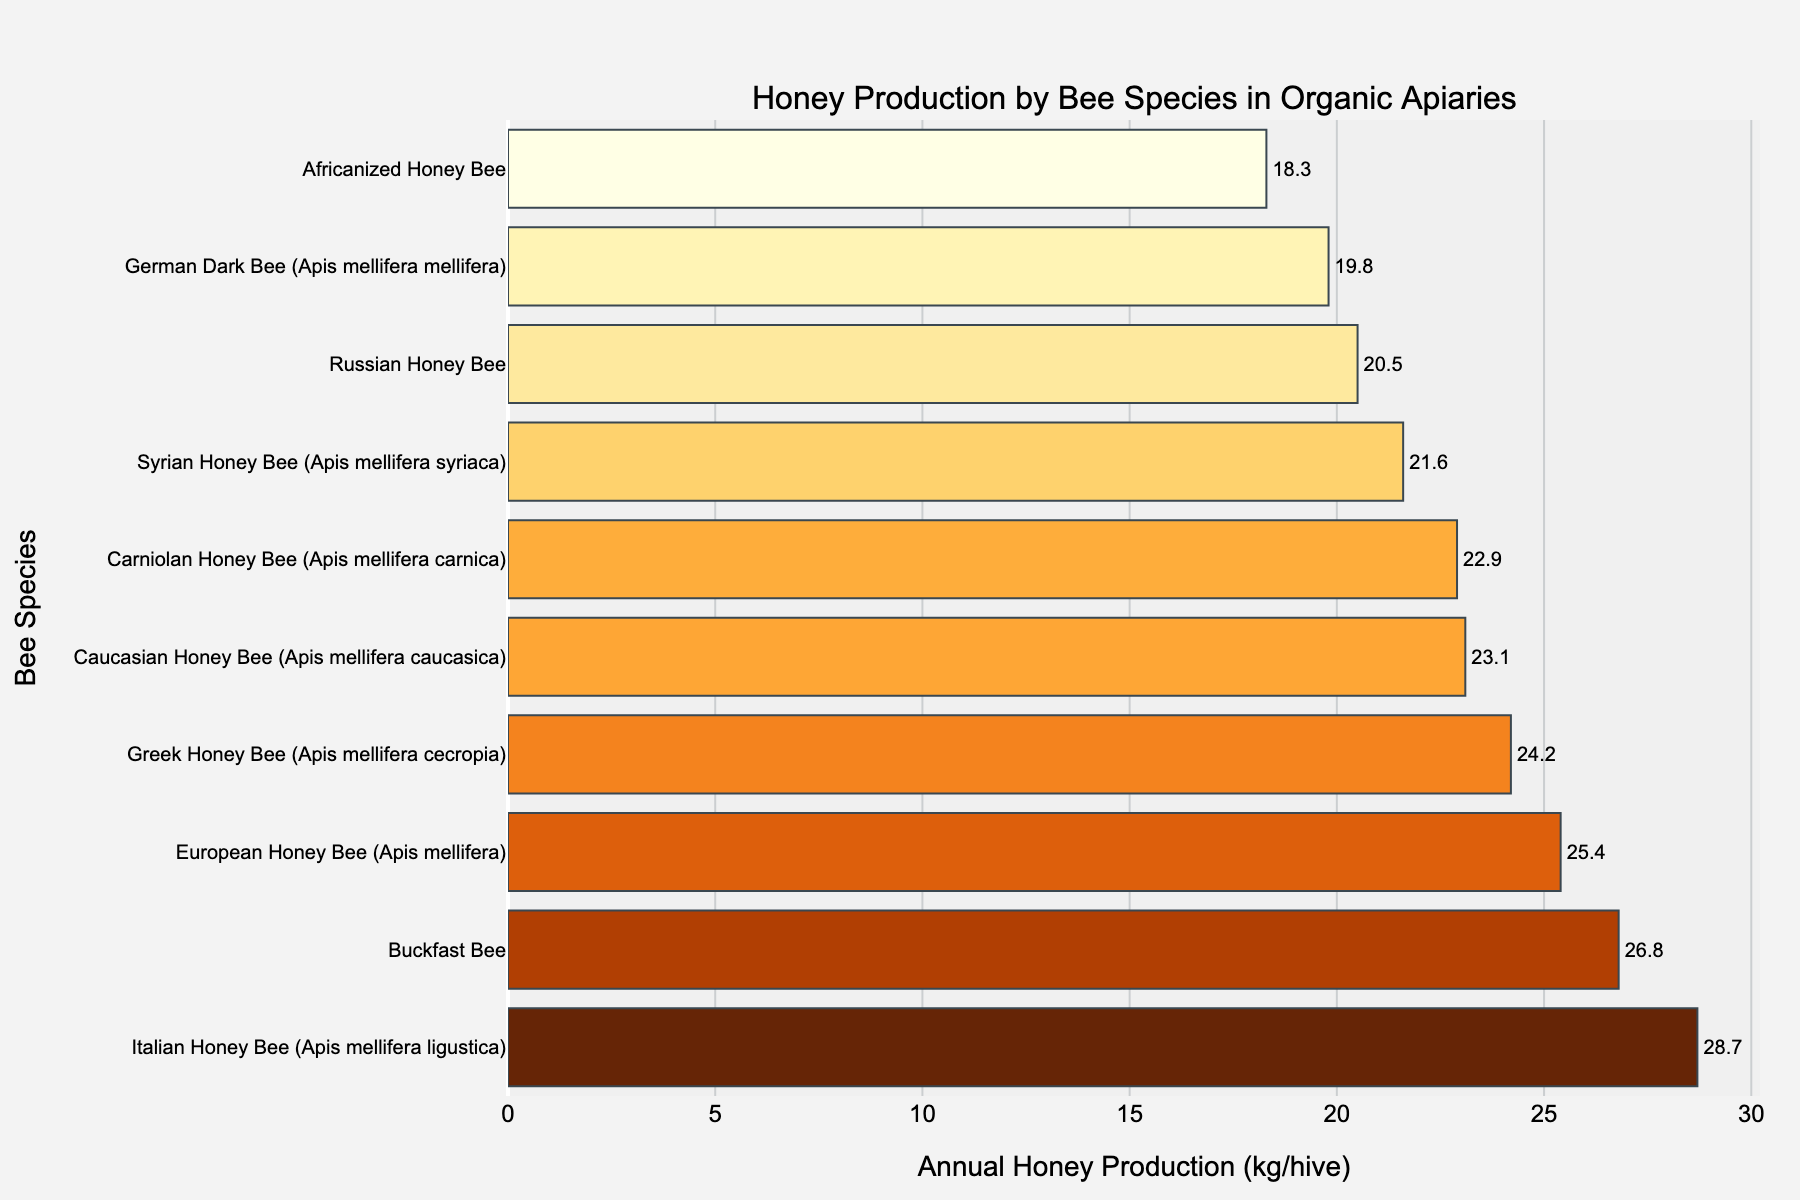Which bee species has the highest annual honey production? The bar chart shows the annual honey production for each bee species. The species with the longest bar has the highest production.
Answer: Italian Honey Bee (Apis mellifera ligustica) Which bee species has the lowest annual honey production? To find the species with the lowest production, look for the shortest bar in the chart.
Answer: Africanized Honey Bee What is the difference in annual honey production between the Italian Honey Bee and the European Honey Bee? Find the lengths of the bars for Italian Honey Bee (28.7 kg/hive) and European Honey Bee (25.4 kg/hive). Subtract the smaller value from the larger value to get the difference.
Answer: 3.3 kg/hive How many bee species have an annual honey production greater than 25 kg per hive? Count the number of bars that extend beyond the 25 kg/hive mark.
Answer: 3 Among the species listed, which one is closest to the median annual honey production value? First, list all production values in ascending order: 18.3, 19.8, 20.5, 21.6, 22.9, 23.1, 24.2, 25.4, 26.8, 28.7. The median value is the middle one (or average of the two middle ones if the list is even), which is the average of the 5th and 6th values: (22.9 + 23.1) / 2 = 23 kg/hive. The species closest to 23 kg is Caucasian Honey Bee.
Answer: Caucasian Honey Bee (Apis mellifera caucasica) What is the combined annual honey production of the Russian Honey Bee and the German Dark Bee? Add the production values of both species: 20.5 kg (Russian Honey Bee) + 19.8 kg (German Dark Bee).
Answer: 40.3 kg/hive List the bee species that produce less than 20 kg of honey annually. Identify the bars that fall short of the 20 kg/hive mark to list their corresponding species.
Answer: German Dark Bee (Apis mellifera mellifera), Africanized Honey Bee Which bee species is positioned between the Greek Honey Bee and Caucasian Honey Bee in terms of annual honey production? When ordered by the production values, the sequence is: Greek Honey Bee (24.2 kg/hive), European Honey Bee (25.4 kg/hive), Buckfast Bee (26.8 kg/hive). Thus, the species between Greek and Caucasian Honey Bee is the European Honey Bee.
Answer: European Honey Bee (Apis mellifera) What is the visual pattern for species with production between 20 kg and 25 kg? Identify the bars that fall within the 20-25 kg range. These bars will have varied lengths but are grouped together within this range in the chart. The species are Russian, Caucasian, Carniolan, Syrian, and Greek Honey Bees.
Answer: A mix of medium-length bars in the chart, representing Russian, Caucasian, Carniolan, Syrian, and Greek Honey Bees 